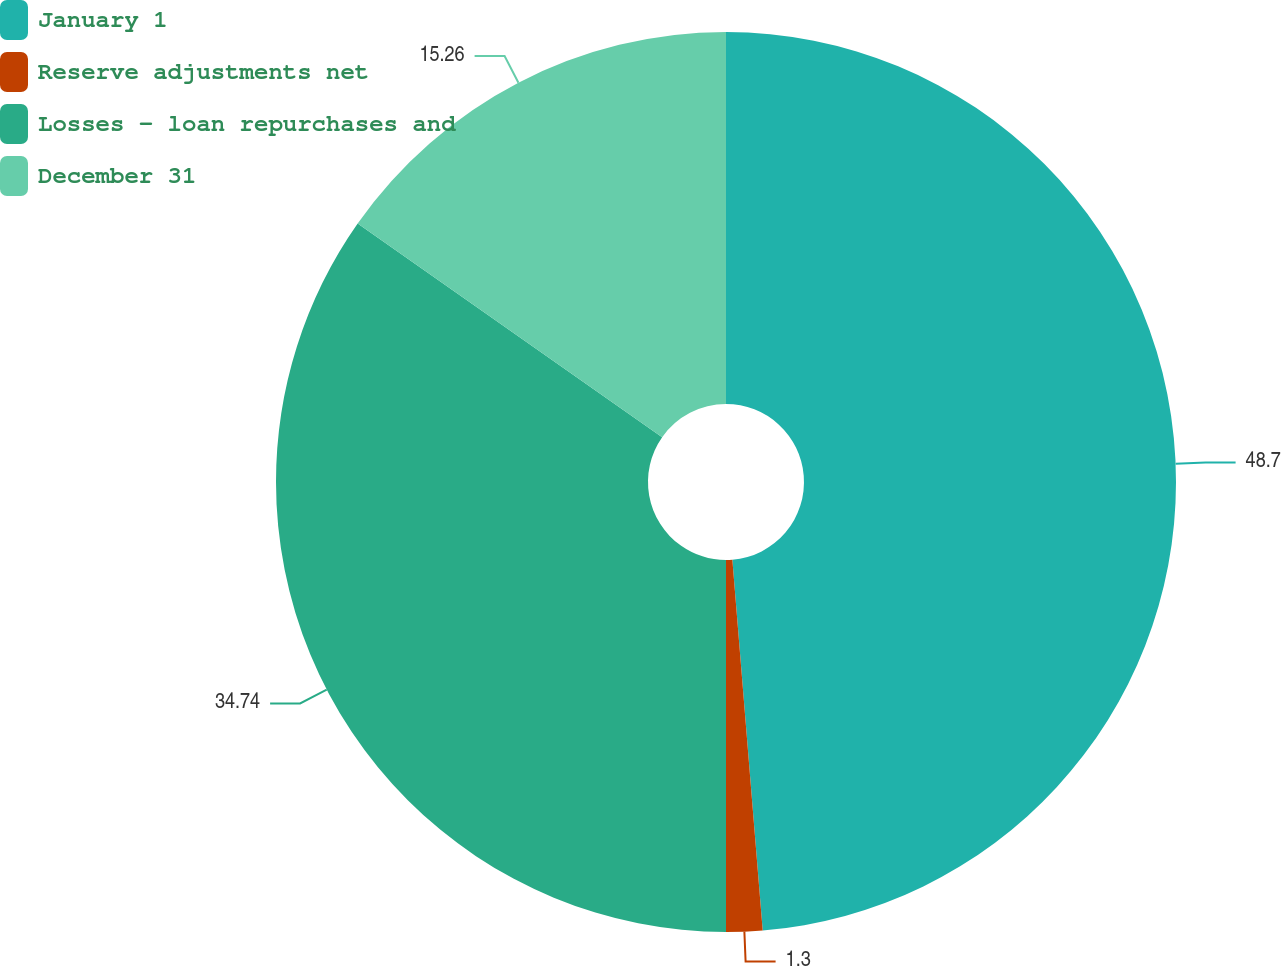Convert chart. <chart><loc_0><loc_0><loc_500><loc_500><pie_chart><fcel>January 1<fcel>Reserve adjustments net<fcel>Losses - loan repurchases and<fcel>December 31<nl><fcel>48.7%<fcel>1.3%<fcel>34.74%<fcel>15.26%<nl></chart> 